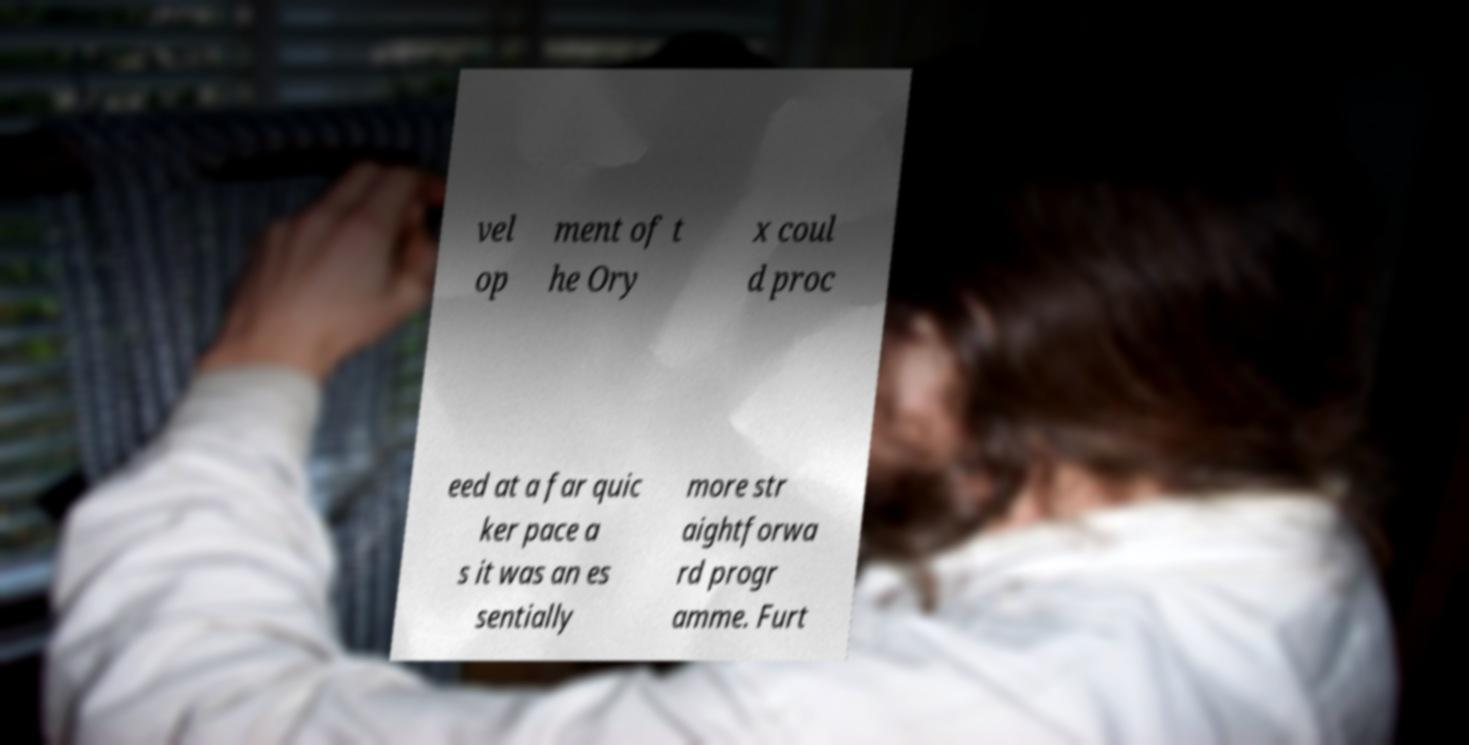Please identify and transcribe the text found in this image. vel op ment of t he Ory x coul d proc eed at a far quic ker pace a s it was an es sentially more str aightforwa rd progr amme. Furt 